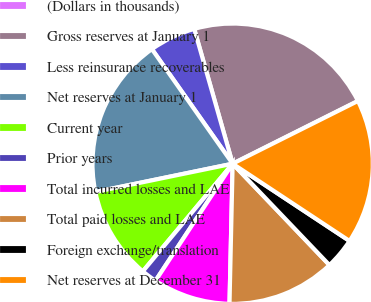<chart> <loc_0><loc_0><loc_500><loc_500><pie_chart><fcel>(Dollars in thousands)<fcel>Gross reserves at January 1<fcel>Less reinsurance recoverables<fcel>Net reserves at January 1<fcel>Current year<fcel>Prior years<fcel>Total incurred losses and LAE<fcel>Total paid losses and LAE<fcel>Foreign exchange/translation<fcel>Net reserves at December 31<nl><fcel>0.0%<fcel>22.03%<fcel>5.35%<fcel>18.46%<fcel>10.7%<fcel>1.79%<fcel>8.92%<fcel>12.49%<fcel>3.57%<fcel>16.68%<nl></chart> 